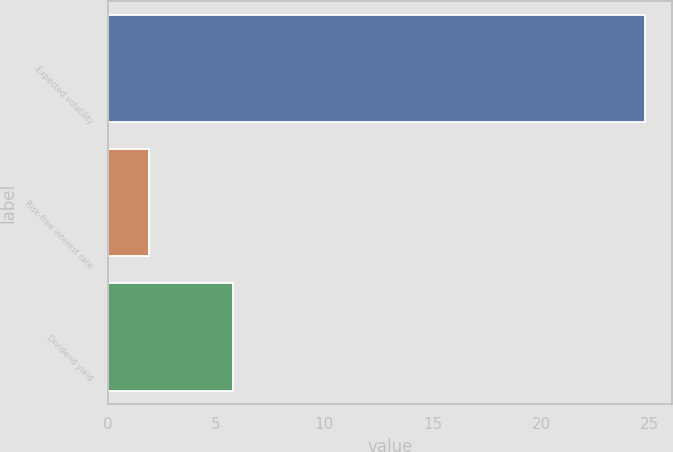Convert chart. <chart><loc_0><loc_0><loc_500><loc_500><bar_chart><fcel>Expected volatility<fcel>Risk-free interest rate<fcel>Dividend yield<nl><fcel>24.8<fcel>1.9<fcel>5.8<nl></chart> 